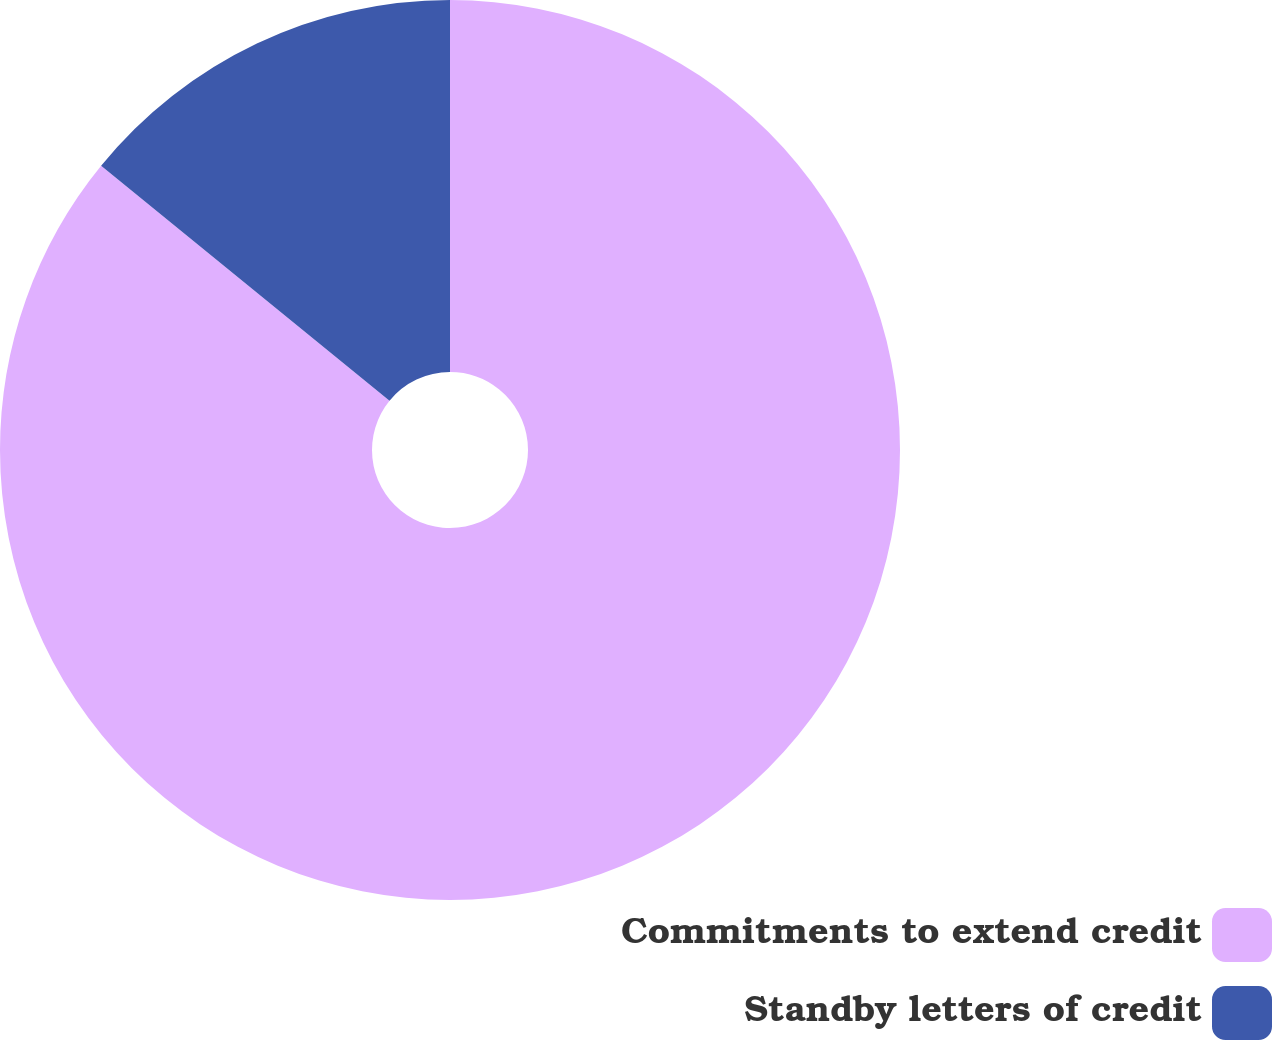Convert chart. <chart><loc_0><loc_0><loc_500><loc_500><pie_chart><fcel>Commitments to extend credit<fcel>Standby letters of credit<nl><fcel>85.88%<fcel>14.12%<nl></chart> 